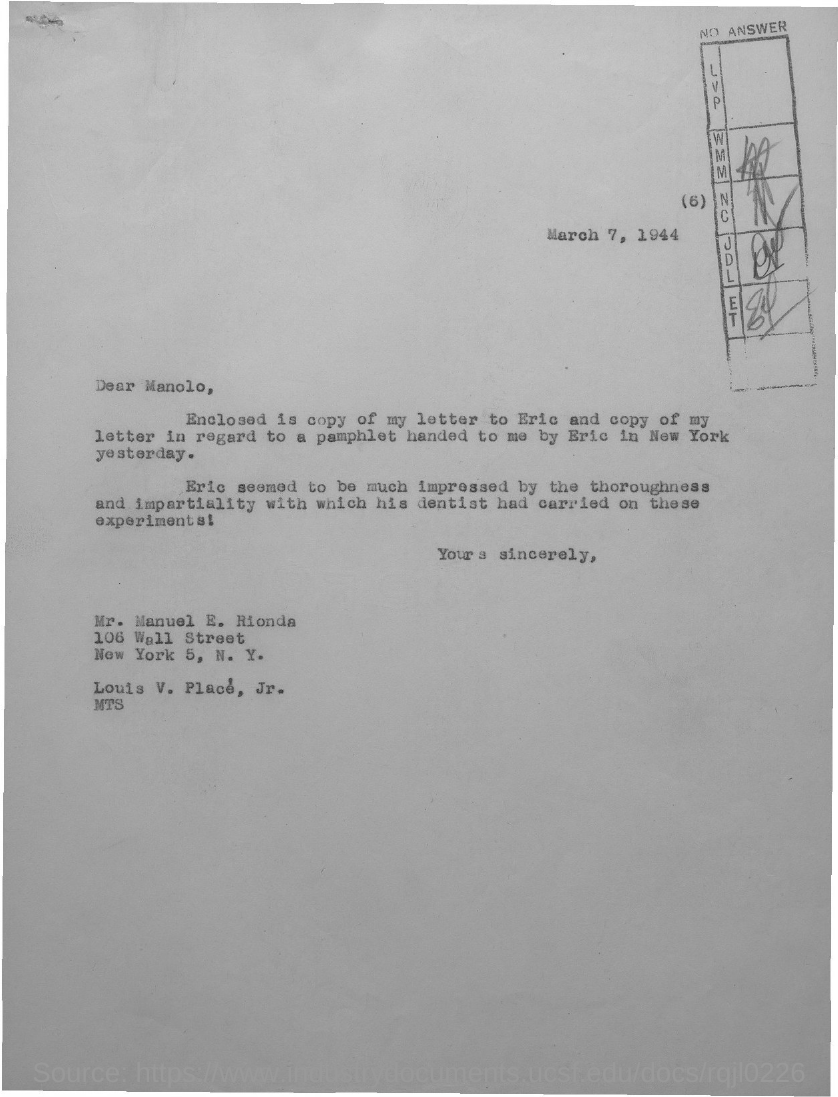Give some essential details in this illustration. The letter is addressed to Manolo. The pamphlet was handed by Eric in New York. The date on the document is March 7, 1944. 